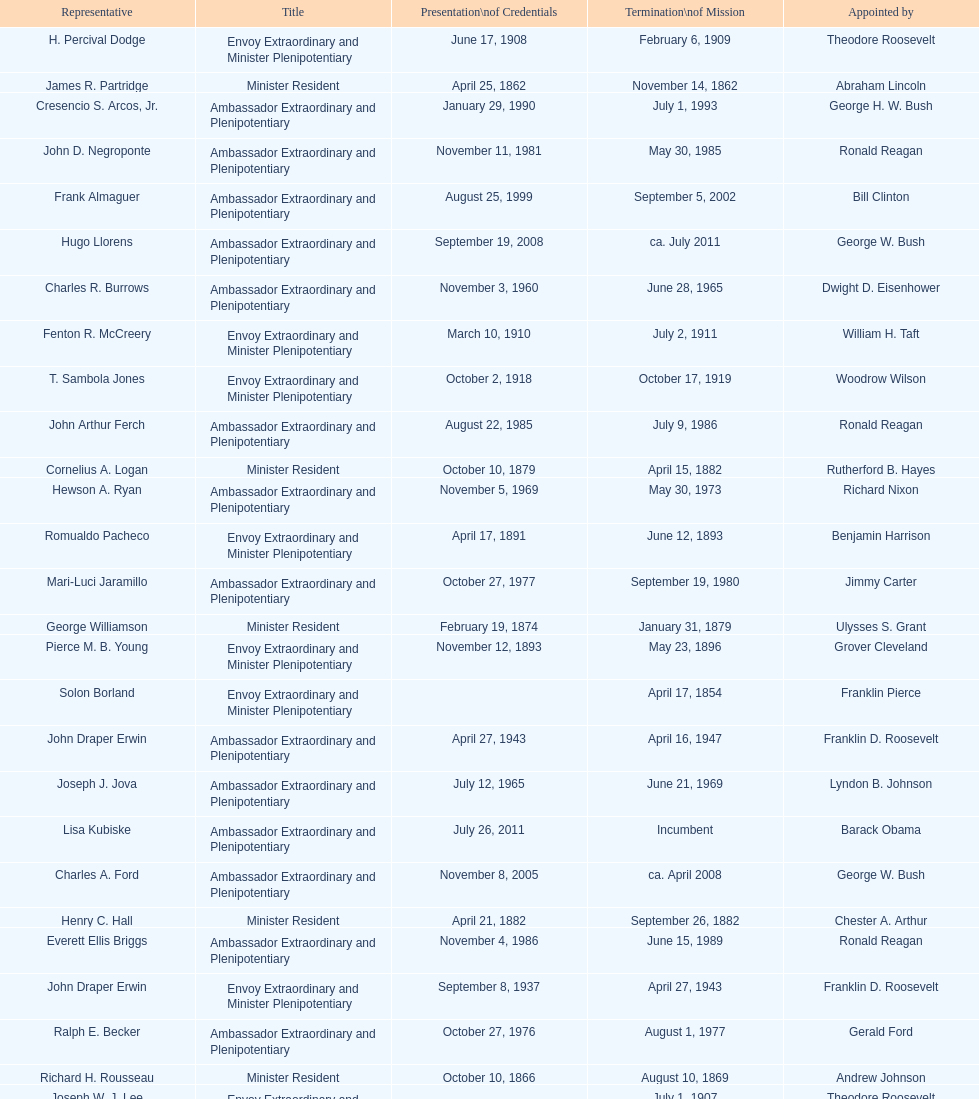Which minister resident had the shortest appointment? Henry C. Hall. 